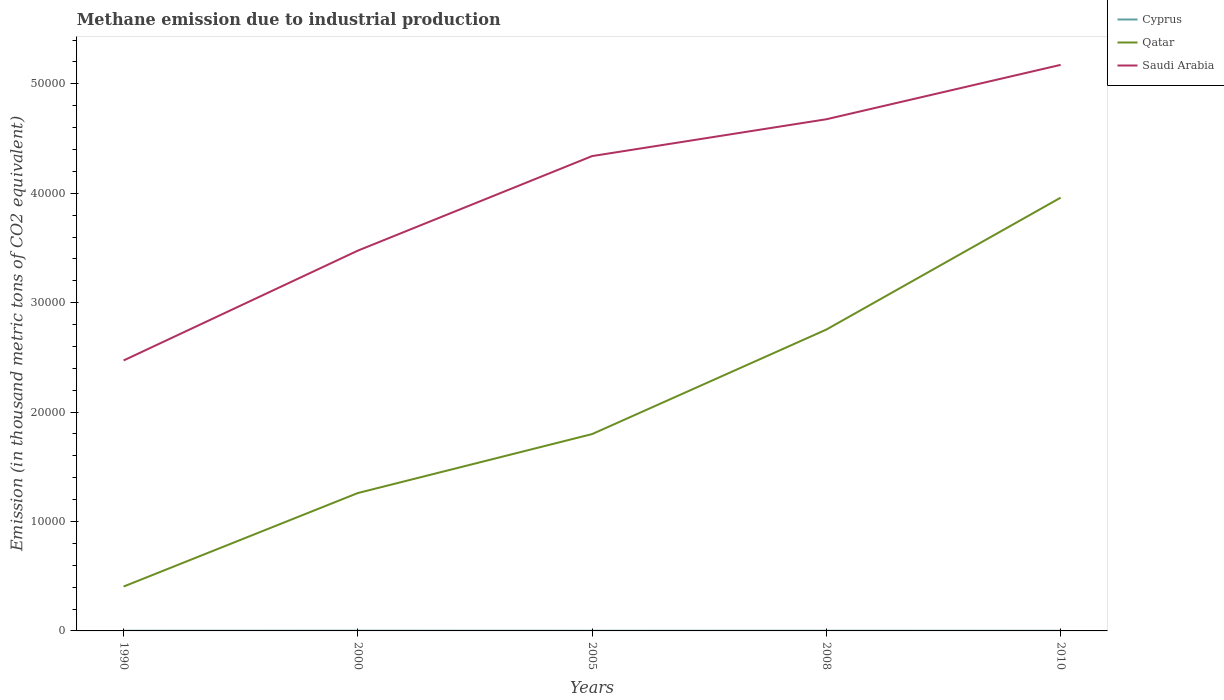Across all years, what is the maximum amount of methane emitted in Qatar?
Your answer should be compact. 4055.8. In which year was the amount of methane emitted in Saudi Arabia maximum?
Keep it short and to the point. 1990. What is the total amount of methane emitted in Qatar in the graph?
Keep it short and to the point. -9553.4. What is the difference between the highest and the second highest amount of methane emitted in Cyprus?
Provide a short and direct response. 8.4. Are the values on the major ticks of Y-axis written in scientific E-notation?
Provide a short and direct response. No. Does the graph contain grids?
Provide a short and direct response. No. How many legend labels are there?
Your response must be concise. 3. How are the legend labels stacked?
Your response must be concise. Vertical. What is the title of the graph?
Ensure brevity in your answer.  Methane emission due to industrial production. What is the label or title of the Y-axis?
Make the answer very short. Emission (in thousand metric tons of CO2 equivalent). What is the Emission (in thousand metric tons of CO2 equivalent) of Qatar in 1990?
Your answer should be very brief. 4055.8. What is the Emission (in thousand metric tons of CO2 equivalent) in Saudi Arabia in 1990?
Offer a very short reply. 2.47e+04. What is the Emission (in thousand metric tons of CO2 equivalent) in Cyprus in 2000?
Provide a succinct answer. 21.7. What is the Emission (in thousand metric tons of CO2 equivalent) in Qatar in 2000?
Keep it short and to the point. 1.26e+04. What is the Emission (in thousand metric tons of CO2 equivalent) of Saudi Arabia in 2000?
Make the answer very short. 3.48e+04. What is the Emission (in thousand metric tons of CO2 equivalent) of Cyprus in 2005?
Offer a terse response. 13.7. What is the Emission (in thousand metric tons of CO2 equivalent) of Qatar in 2005?
Your answer should be compact. 1.80e+04. What is the Emission (in thousand metric tons of CO2 equivalent) of Saudi Arabia in 2005?
Keep it short and to the point. 4.34e+04. What is the Emission (in thousand metric tons of CO2 equivalent) in Cyprus in 2008?
Your answer should be very brief. 16. What is the Emission (in thousand metric tons of CO2 equivalent) in Qatar in 2008?
Your response must be concise. 2.75e+04. What is the Emission (in thousand metric tons of CO2 equivalent) of Saudi Arabia in 2008?
Offer a terse response. 4.68e+04. What is the Emission (in thousand metric tons of CO2 equivalent) in Cyprus in 2010?
Offer a terse response. 13.3. What is the Emission (in thousand metric tons of CO2 equivalent) of Qatar in 2010?
Your response must be concise. 3.96e+04. What is the Emission (in thousand metric tons of CO2 equivalent) in Saudi Arabia in 2010?
Offer a terse response. 5.17e+04. Across all years, what is the maximum Emission (in thousand metric tons of CO2 equivalent) in Cyprus?
Your answer should be very brief. 21.7. Across all years, what is the maximum Emission (in thousand metric tons of CO2 equivalent) of Qatar?
Your answer should be very brief. 3.96e+04. Across all years, what is the maximum Emission (in thousand metric tons of CO2 equivalent) in Saudi Arabia?
Your answer should be very brief. 5.17e+04. Across all years, what is the minimum Emission (in thousand metric tons of CO2 equivalent) in Qatar?
Provide a succinct answer. 4055.8. Across all years, what is the minimum Emission (in thousand metric tons of CO2 equivalent) in Saudi Arabia?
Offer a very short reply. 2.47e+04. What is the total Emission (in thousand metric tons of CO2 equivalent) of Cyprus in the graph?
Provide a succinct answer. 79.4. What is the total Emission (in thousand metric tons of CO2 equivalent) of Qatar in the graph?
Provide a succinct answer. 1.02e+05. What is the total Emission (in thousand metric tons of CO2 equivalent) of Saudi Arabia in the graph?
Give a very brief answer. 2.01e+05. What is the difference between the Emission (in thousand metric tons of CO2 equivalent) of Cyprus in 1990 and that in 2000?
Your response must be concise. -7. What is the difference between the Emission (in thousand metric tons of CO2 equivalent) of Qatar in 1990 and that in 2000?
Offer a terse response. -8547.3. What is the difference between the Emission (in thousand metric tons of CO2 equivalent) in Saudi Arabia in 1990 and that in 2000?
Make the answer very short. -1.00e+04. What is the difference between the Emission (in thousand metric tons of CO2 equivalent) of Qatar in 1990 and that in 2005?
Provide a short and direct response. -1.39e+04. What is the difference between the Emission (in thousand metric tons of CO2 equivalent) in Saudi Arabia in 1990 and that in 2005?
Offer a very short reply. -1.87e+04. What is the difference between the Emission (in thousand metric tons of CO2 equivalent) of Cyprus in 1990 and that in 2008?
Give a very brief answer. -1.3. What is the difference between the Emission (in thousand metric tons of CO2 equivalent) of Qatar in 1990 and that in 2008?
Your answer should be compact. -2.35e+04. What is the difference between the Emission (in thousand metric tons of CO2 equivalent) in Saudi Arabia in 1990 and that in 2008?
Ensure brevity in your answer.  -2.20e+04. What is the difference between the Emission (in thousand metric tons of CO2 equivalent) of Cyprus in 1990 and that in 2010?
Your answer should be compact. 1.4. What is the difference between the Emission (in thousand metric tons of CO2 equivalent) of Qatar in 1990 and that in 2010?
Offer a terse response. -3.55e+04. What is the difference between the Emission (in thousand metric tons of CO2 equivalent) of Saudi Arabia in 1990 and that in 2010?
Make the answer very short. -2.70e+04. What is the difference between the Emission (in thousand metric tons of CO2 equivalent) in Cyprus in 2000 and that in 2005?
Your response must be concise. 8. What is the difference between the Emission (in thousand metric tons of CO2 equivalent) of Qatar in 2000 and that in 2005?
Your answer should be very brief. -5388.1. What is the difference between the Emission (in thousand metric tons of CO2 equivalent) of Saudi Arabia in 2000 and that in 2005?
Make the answer very short. -8641.3. What is the difference between the Emission (in thousand metric tons of CO2 equivalent) of Qatar in 2000 and that in 2008?
Make the answer very short. -1.49e+04. What is the difference between the Emission (in thousand metric tons of CO2 equivalent) of Saudi Arabia in 2000 and that in 2008?
Offer a very short reply. -1.20e+04. What is the difference between the Emission (in thousand metric tons of CO2 equivalent) in Qatar in 2000 and that in 2010?
Ensure brevity in your answer.  -2.70e+04. What is the difference between the Emission (in thousand metric tons of CO2 equivalent) in Saudi Arabia in 2000 and that in 2010?
Give a very brief answer. -1.70e+04. What is the difference between the Emission (in thousand metric tons of CO2 equivalent) in Cyprus in 2005 and that in 2008?
Make the answer very short. -2.3. What is the difference between the Emission (in thousand metric tons of CO2 equivalent) of Qatar in 2005 and that in 2008?
Offer a very short reply. -9553.4. What is the difference between the Emission (in thousand metric tons of CO2 equivalent) of Saudi Arabia in 2005 and that in 2008?
Offer a terse response. -3365.4. What is the difference between the Emission (in thousand metric tons of CO2 equivalent) in Cyprus in 2005 and that in 2010?
Offer a terse response. 0.4. What is the difference between the Emission (in thousand metric tons of CO2 equivalent) of Qatar in 2005 and that in 2010?
Give a very brief answer. -2.16e+04. What is the difference between the Emission (in thousand metric tons of CO2 equivalent) of Saudi Arabia in 2005 and that in 2010?
Offer a terse response. -8336. What is the difference between the Emission (in thousand metric tons of CO2 equivalent) of Cyprus in 2008 and that in 2010?
Give a very brief answer. 2.7. What is the difference between the Emission (in thousand metric tons of CO2 equivalent) of Qatar in 2008 and that in 2010?
Provide a succinct answer. -1.21e+04. What is the difference between the Emission (in thousand metric tons of CO2 equivalent) of Saudi Arabia in 2008 and that in 2010?
Provide a short and direct response. -4970.6. What is the difference between the Emission (in thousand metric tons of CO2 equivalent) in Cyprus in 1990 and the Emission (in thousand metric tons of CO2 equivalent) in Qatar in 2000?
Keep it short and to the point. -1.26e+04. What is the difference between the Emission (in thousand metric tons of CO2 equivalent) of Cyprus in 1990 and the Emission (in thousand metric tons of CO2 equivalent) of Saudi Arabia in 2000?
Ensure brevity in your answer.  -3.47e+04. What is the difference between the Emission (in thousand metric tons of CO2 equivalent) in Qatar in 1990 and the Emission (in thousand metric tons of CO2 equivalent) in Saudi Arabia in 2000?
Your response must be concise. -3.07e+04. What is the difference between the Emission (in thousand metric tons of CO2 equivalent) of Cyprus in 1990 and the Emission (in thousand metric tons of CO2 equivalent) of Qatar in 2005?
Your answer should be very brief. -1.80e+04. What is the difference between the Emission (in thousand metric tons of CO2 equivalent) of Cyprus in 1990 and the Emission (in thousand metric tons of CO2 equivalent) of Saudi Arabia in 2005?
Provide a short and direct response. -4.34e+04. What is the difference between the Emission (in thousand metric tons of CO2 equivalent) of Qatar in 1990 and the Emission (in thousand metric tons of CO2 equivalent) of Saudi Arabia in 2005?
Offer a terse response. -3.93e+04. What is the difference between the Emission (in thousand metric tons of CO2 equivalent) of Cyprus in 1990 and the Emission (in thousand metric tons of CO2 equivalent) of Qatar in 2008?
Ensure brevity in your answer.  -2.75e+04. What is the difference between the Emission (in thousand metric tons of CO2 equivalent) of Cyprus in 1990 and the Emission (in thousand metric tons of CO2 equivalent) of Saudi Arabia in 2008?
Provide a short and direct response. -4.68e+04. What is the difference between the Emission (in thousand metric tons of CO2 equivalent) in Qatar in 1990 and the Emission (in thousand metric tons of CO2 equivalent) in Saudi Arabia in 2008?
Offer a terse response. -4.27e+04. What is the difference between the Emission (in thousand metric tons of CO2 equivalent) in Cyprus in 1990 and the Emission (in thousand metric tons of CO2 equivalent) in Qatar in 2010?
Offer a very short reply. -3.96e+04. What is the difference between the Emission (in thousand metric tons of CO2 equivalent) in Cyprus in 1990 and the Emission (in thousand metric tons of CO2 equivalent) in Saudi Arabia in 2010?
Offer a very short reply. -5.17e+04. What is the difference between the Emission (in thousand metric tons of CO2 equivalent) of Qatar in 1990 and the Emission (in thousand metric tons of CO2 equivalent) of Saudi Arabia in 2010?
Ensure brevity in your answer.  -4.77e+04. What is the difference between the Emission (in thousand metric tons of CO2 equivalent) of Cyprus in 2000 and the Emission (in thousand metric tons of CO2 equivalent) of Qatar in 2005?
Offer a terse response. -1.80e+04. What is the difference between the Emission (in thousand metric tons of CO2 equivalent) in Cyprus in 2000 and the Emission (in thousand metric tons of CO2 equivalent) in Saudi Arabia in 2005?
Make the answer very short. -4.34e+04. What is the difference between the Emission (in thousand metric tons of CO2 equivalent) of Qatar in 2000 and the Emission (in thousand metric tons of CO2 equivalent) of Saudi Arabia in 2005?
Offer a terse response. -3.08e+04. What is the difference between the Emission (in thousand metric tons of CO2 equivalent) of Cyprus in 2000 and the Emission (in thousand metric tons of CO2 equivalent) of Qatar in 2008?
Provide a succinct answer. -2.75e+04. What is the difference between the Emission (in thousand metric tons of CO2 equivalent) of Cyprus in 2000 and the Emission (in thousand metric tons of CO2 equivalent) of Saudi Arabia in 2008?
Provide a succinct answer. -4.67e+04. What is the difference between the Emission (in thousand metric tons of CO2 equivalent) of Qatar in 2000 and the Emission (in thousand metric tons of CO2 equivalent) of Saudi Arabia in 2008?
Provide a succinct answer. -3.42e+04. What is the difference between the Emission (in thousand metric tons of CO2 equivalent) in Cyprus in 2000 and the Emission (in thousand metric tons of CO2 equivalent) in Qatar in 2010?
Ensure brevity in your answer.  -3.96e+04. What is the difference between the Emission (in thousand metric tons of CO2 equivalent) in Cyprus in 2000 and the Emission (in thousand metric tons of CO2 equivalent) in Saudi Arabia in 2010?
Offer a very short reply. -5.17e+04. What is the difference between the Emission (in thousand metric tons of CO2 equivalent) of Qatar in 2000 and the Emission (in thousand metric tons of CO2 equivalent) of Saudi Arabia in 2010?
Give a very brief answer. -3.91e+04. What is the difference between the Emission (in thousand metric tons of CO2 equivalent) of Cyprus in 2005 and the Emission (in thousand metric tons of CO2 equivalent) of Qatar in 2008?
Provide a succinct answer. -2.75e+04. What is the difference between the Emission (in thousand metric tons of CO2 equivalent) in Cyprus in 2005 and the Emission (in thousand metric tons of CO2 equivalent) in Saudi Arabia in 2008?
Keep it short and to the point. -4.68e+04. What is the difference between the Emission (in thousand metric tons of CO2 equivalent) of Qatar in 2005 and the Emission (in thousand metric tons of CO2 equivalent) of Saudi Arabia in 2008?
Make the answer very short. -2.88e+04. What is the difference between the Emission (in thousand metric tons of CO2 equivalent) of Cyprus in 2005 and the Emission (in thousand metric tons of CO2 equivalent) of Qatar in 2010?
Your answer should be very brief. -3.96e+04. What is the difference between the Emission (in thousand metric tons of CO2 equivalent) of Cyprus in 2005 and the Emission (in thousand metric tons of CO2 equivalent) of Saudi Arabia in 2010?
Offer a very short reply. -5.17e+04. What is the difference between the Emission (in thousand metric tons of CO2 equivalent) in Qatar in 2005 and the Emission (in thousand metric tons of CO2 equivalent) in Saudi Arabia in 2010?
Your answer should be very brief. -3.37e+04. What is the difference between the Emission (in thousand metric tons of CO2 equivalent) of Cyprus in 2008 and the Emission (in thousand metric tons of CO2 equivalent) of Qatar in 2010?
Make the answer very short. -3.96e+04. What is the difference between the Emission (in thousand metric tons of CO2 equivalent) of Cyprus in 2008 and the Emission (in thousand metric tons of CO2 equivalent) of Saudi Arabia in 2010?
Your answer should be very brief. -5.17e+04. What is the difference between the Emission (in thousand metric tons of CO2 equivalent) in Qatar in 2008 and the Emission (in thousand metric tons of CO2 equivalent) in Saudi Arabia in 2010?
Your answer should be very brief. -2.42e+04. What is the average Emission (in thousand metric tons of CO2 equivalent) of Cyprus per year?
Your answer should be compact. 15.88. What is the average Emission (in thousand metric tons of CO2 equivalent) in Qatar per year?
Provide a succinct answer. 2.04e+04. What is the average Emission (in thousand metric tons of CO2 equivalent) in Saudi Arabia per year?
Your answer should be very brief. 4.03e+04. In the year 1990, what is the difference between the Emission (in thousand metric tons of CO2 equivalent) of Cyprus and Emission (in thousand metric tons of CO2 equivalent) of Qatar?
Make the answer very short. -4041.1. In the year 1990, what is the difference between the Emission (in thousand metric tons of CO2 equivalent) of Cyprus and Emission (in thousand metric tons of CO2 equivalent) of Saudi Arabia?
Ensure brevity in your answer.  -2.47e+04. In the year 1990, what is the difference between the Emission (in thousand metric tons of CO2 equivalent) of Qatar and Emission (in thousand metric tons of CO2 equivalent) of Saudi Arabia?
Keep it short and to the point. -2.07e+04. In the year 2000, what is the difference between the Emission (in thousand metric tons of CO2 equivalent) of Cyprus and Emission (in thousand metric tons of CO2 equivalent) of Qatar?
Make the answer very short. -1.26e+04. In the year 2000, what is the difference between the Emission (in thousand metric tons of CO2 equivalent) in Cyprus and Emission (in thousand metric tons of CO2 equivalent) in Saudi Arabia?
Your answer should be very brief. -3.47e+04. In the year 2000, what is the difference between the Emission (in thousand metric tons of CO2 equivalent) of Qatar and Emission (in thousand metric tons of CO2 equivalent) of Saudi Arabia?
Give a very brief answer. -2.22e+04. In the year 2005, what is the difference between the Emission (in thousand metric tons of CO2 equivalent) in Cyprus and Emission (in thousand metric tons of CO2 equivalent) in Qatar?
Offer a terse response. -1.80e+04. In the year 2005, what is the difference between the Emission (in thousand metric tons of CO2 equivalent) of Cyprus and Emission (in thousand metric tons of CO2 equivalent) of Saudi Arabia?
Provide a short and direct response. -4.34e+04. In the year 2005, what is the difference between the Emission (in thousand metric tons of CO2 equivalent) in Qatar and Emission (in thousand metric tons of CO2 equivalent) in Saudi Arabia?
Ensure brevity in your answer.  -2.54e+04. In the year 2008, what is the difference between the Emission (in thousand metric tons of CO2 equivalent) of Cyprus and Emission (in thousand metric tons of CO2 equivalent) of Qatar?
Your response must be concise. -2.75e+04. In the year 2008, what is the difference between the Emission (in thousand metric tons of CO2 equivalent) of Cyprus and Emission (in thousand metric tons of CO2 equivalent) of Saudi Arabia?
Give a very brief answer. -4.67e+04. In the year 2008, what is the difference between the Emission (in thousand metric tons of CO2 equivalent) of Qatar and Emission (in thousand metric tons of CO2 equivalent) of Saudi Arabia?
Your response must be concise. -1.92e+04. In the year 2010, what is the difference between the Emission (in thousand metric tons of CO2 equivalent) of Cyprus and Emission (in thousand metric tons of CO2 equivalent) of Qatar?
Provide a short and direct response. -3.96e+04. In the year 2010, what is the difference between the Emission (in thousand metric tons of CO2 equivalent) of Cyprus and Emission (in thousand metric tons of CO2 equivalent) of Saudi Arabia?
Provide a succinct answer. -5.17e+04. In the year 2010, what is the difference between the Emission (in thousand metric tons of CO2 equivalent) in Qatar and Emission (in thousand metric tons of CO2 equivalent) in Saudi Arabia?
Ensure brevity in your answer.  -1.21e+04. What is the ratio of the Emission (in thousand metric tons of CO2 equivalent) in Cyprus in 1990 to that in 2000?
Your answer should be compact. 0.68. What is the ratio of the Emission (in thousand metric tons of CO2 equivalent) in Qatar in 1990 to that in 2000?
Offer a terse response. 0.32. What is the ratio of the Emission (in thousand metric tons of CO2 equivalent) in Saudi Arabia in 1990 to that in 2000?
Offer a terse response. 0.71. What is the ratio of the Emission (in thousand metric tons of CO2 equivalent) in Cyprus in 1990 to that in 2005?
Keep it short and to the point. 1.07. What is the ratio of the Emission (in thousand metric tons of CO2 equivalent) in Qatar in 1990 to that in 2005?
Make the answer very short. 0.23. What is the ratio of the Emission (in thousand metric tons of CO2 equivalent) in Saudi Arabia in 1990 to that in 2005?
Keep it short and to the point. 0.57. What is the ratio of the Emission (in thousand metric tons of CO2 equivalent) in Cyprus in 1990 to that in 2008?
Keep it short and to the point. 0.92. What is the ratio of the Emission (in thousand metric tons of CO2 equivalent) in Qatar in 1990 to that in 2008?
Provide a short and direct response. 0.15. What is the ratio of the Emission (in thousand metric tons of CO2 equivalent) in Saudi Arabia in 1990 to that in 2008?
Your response must be concise. 0.53. What is the ratio of the Emission (in thousand metric tons of CO2 equivalent) in Cyprus in 1990 to that in 2010?
Make the answer very short. 1.11. What is the ratio of the Emission (in thousand metric tons of CO2 equivalent) of Qatar in 1990 to that in 2010?
Make the answer very short. 0.1. What is the ratio of the Emission (in thousand metric tons of CO2 equivalent) in Saudi Arabia in 1990 to that in 2010?
Keep it short and to the point. 0.48. What is the ratio of the Emission (in thousand metric tons of CO2 equivalent) of Cyprus in 2000 to that in 2005?
Make the answer very short. 1.58. What is the ratio of the Emission (in thousand metric tons of CO2 equivalent) in Qatar in 2000 to that in 2005?
Provide a short and direct response. 0.7. What is the ratio of the Emission (in thousand metric tons of CO2 equivalent) of Saudi Arabia in 2000 to that in 2005?
Give a very brief answer. 0.8. What is the ratio of the Emission (in thousand metric tons of CO2 equivalent) of Cyprus in 2000 to that in 2008?
Your answer should be very brief. 1.36. What is the ratio of the Emission (in thousand metric tons of CO2 equivalent) in Qatar in 2000 to that in 2008?
Ensure brevity in your answer.  0.46. What is the ratio of the Emission (in thousand metric tons of CO2 equivalent) of Saudi Arabia in 2000 to that in 2008?
Give a very brief answer. 0.74. What is the ratio of the Emission (in thousand metric tons of CO2 equivalent) of Cyprus in 2000 to that in 2010?
Provide a succinct answer. 1.63. What is the ratio of the Emission (in thousand metric tons of CO2 equivalent) in Qatar in 2000 to that in 2010?
Provide a short and direct response. 0.32. What is the ratio of the Emission (in thousand metric tons of CO2 equivalent) of Saudi Arabia in 2000 to that in 2010?
Keep it short and to the point. 0.67. What is the ratio of the Emission (in thousand metric tons of CO2 equivalent) in Cyprus in 2005 to that in 2008?
Your answer should be very brief. 0.86. What is the ratio of the Emission (in thousand metric tons of CO2 equivalent) of Qatar in 2005 to that in 2008?
Your response must be concise. 0.65. What is the ratio of the Emission (in thousand metric tons of CO2 equivalent) of Saudi Arabia in 2005 to that in 2008?
Give a very brief answer. 0.93. What is the ratio of the Emission (in thousand metric tons of CO2 equivalent) in Cyprus in 2005 to that in 2010?
Your answer should be very brief. 1.03. What is the ratio of the Emission (in thousand metric tons of CO2 equivalent) in Qatar in 2005 to that in 2010?
Give a very brief answer. 0.45. What is the ratio of the Emission (in thousand metric tons of CO2 equivalent) in Saudi Arabia in 2005 to that in 2010?
Keep it short and to the point. 0.84. What is the ratio of the Emission (in thousand metric tons of CO2 equivalent) of Cyprus in 2008 to that in 2010?
Provide a succinct answer. 1.2. What is the ratio of the Emission (in thousand metric tons of CO2 equivalent) of Qatar in 2008 to that in 2010?
Offer a terse response. 0.7. What is the ratio of the Emission (in thousand metric tons of CO2 equivalent) of Saudi Arabia in 2008 to that in 2010?
Make the answer very short. 0.9. What is the difference between the highest and the second highest Emission (in thousand metric tons of CO2 equivalent) of Qatar?
Your answer should be compact. 1.21e+04. What is the difference between the highest and the second highest Emission (in thousand metric tons of CO2 equivalent) of Saudi Arabia?
Keep it short and to the point. 4970.6. What is the difference between the highest and the lowest Emission (in thousand metric tons of CO2 equivalent) of Qatar?
Your answer should be compact. 3.55e+04. What is the difference between the highest and the lowest Emission (in thousand metric tons of CO2 equivalent) in Saudi Arabia?
Your answer should be very brief. 2.70e+04. 